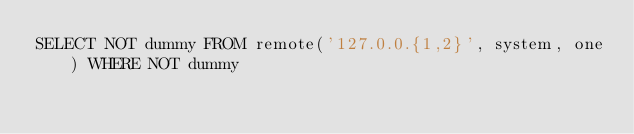<code> <loc_0><loc_0><loc_500><loc_500><_SQL_>SELECT NOT dummy FROM remote('127.0.0.{1,2}', system, one) WHERE NOT dummy
</code> 